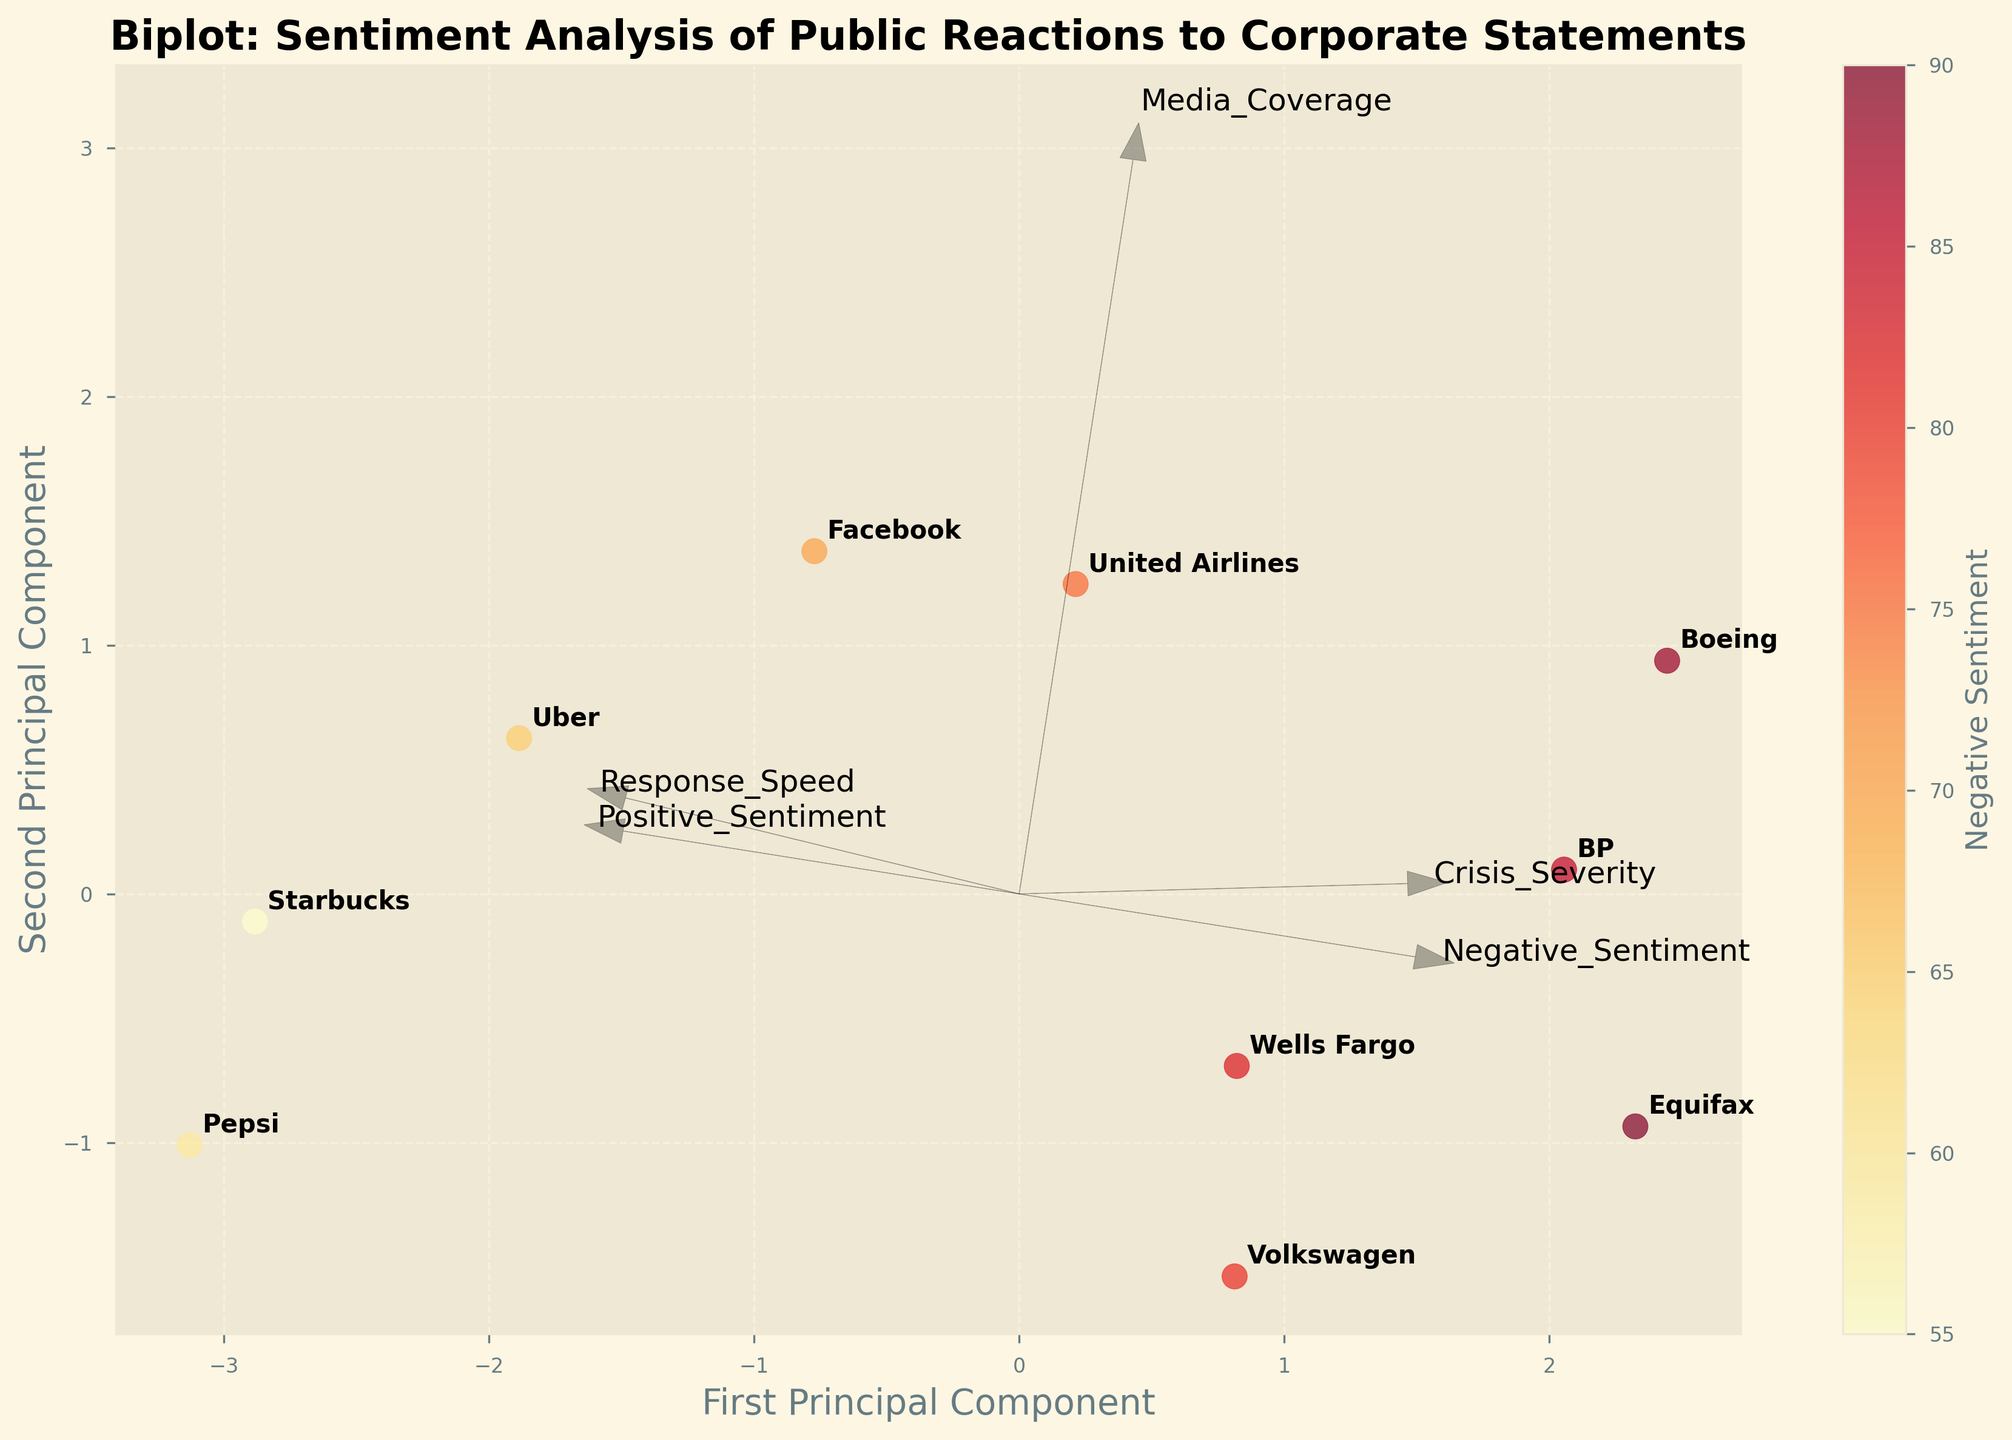How many companies are represented in the biplot? By counting the labels annotated on the data points in the scatter plot, we find that there are 10 different companies.
Answer: 10 Which company has the highest negative sentiment? By observing the color intensity of the data points, the darkest red represents the highest negative sentiment. The company nearest the darkest red data point is Equifax.
Answer: Equifax Which principal component has more influence on the scattering of the data points, the first or the second one? By looking at the spread of the data points along both axes, the first principal component appears to have a wider spread than the second, indicating more influence.
Answer: First principal component What is associated with the highest positive sentiment, according to the plot? By following the direction of the feature vector labeled "Positive_Sentiment," we see that Starbucks and Pepsi are closer to this vector, indicating higher positive sentiments.
Answer: Starbucks and Pepsi Which principal component seems to be more influenced by the Crisis Severity and Media Coverage features? By observing the arrows representing the feature vectors, both "Crisis_Severity" and "Media_Coverage" point more strongly in the direction of the first principal component.
Answer: First principal component Between BP and Starbucks, which company has a quicker response speed? By locating BP and Starbucks on the plot and examining their proximity to the "Response_Speed" vector, Starbucks is closer, indicating a quicker response speed.
Answer: Starbucks How does Uber's position compare to Wells Fargo in terms of positive sentiment and response speed? Uber is positioned higher along the first principal component, indicating higher positive sentiment. It is also closer to the "Response_Speed" vector, indicating a quicker response.
Answer: Uber has higher positive sentiment and quicker response What can you infer about Facebook's crisis severity compared to Boeing's? Facebook is positioned further from the "Crisis_Severity" vector compared to Boeing, implying that Facebook's crisis severity is lower.
Answer: Facebook's crisis severity is lower than Boeing's Which feature vectors appear to be negatively correlated based on their directions in the biplot? Feature vectors pointing in nearly opposite directions indicate a negative correlation. "Positive_Sentiment" and "Negative_Sentiment" vectors point in roughly opposite directions, suggesting that these features are negatively correlated.
Answer: Positive_Sentiment and Negative_Sentiment How does Media Coverage influence the positioning of the companies on the plot? Companies nearer to the "Media_Coverage" vector, such as United Airlines and Boeing, are likely to have higher media coverage. Those further away, like Pepsi and Volkswagen, have relatively less media coverage.
Answer: United Airlines and Boeing have higher media coverage, Pepsi and Volkswagen have less 